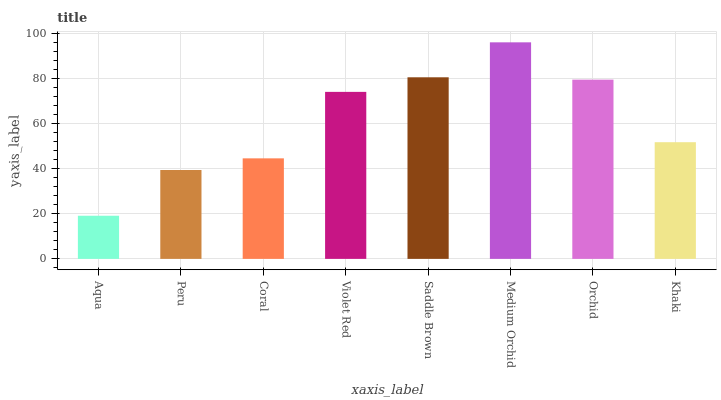Is Aqua the minimum?
Answer yes or no. Yes. Is Medium Orchid the maximum?
Answer yes or no. Yes. Is Peru the minimum?
Answer yes or no. No. Is Peru the maximum?
Answer yes or no. No. Is Peru greater than Aqua?
Answer yes or no. Yes. Is Aqua less than Peru?
Answer yes or no. Yes. Is Aqua greater than Peru?
Answer yes or no. No. Is Peru less than Aqua?
Answer yes or no. No. Is Violet Red the high median?
Answer yes or no. Yes. Is Khaki the low median?
Answer yes or no. Yes. Is Medium Orchid the high median?
Answer yes or no. No. Is Peru the low median?
Answer yes or no. No. 